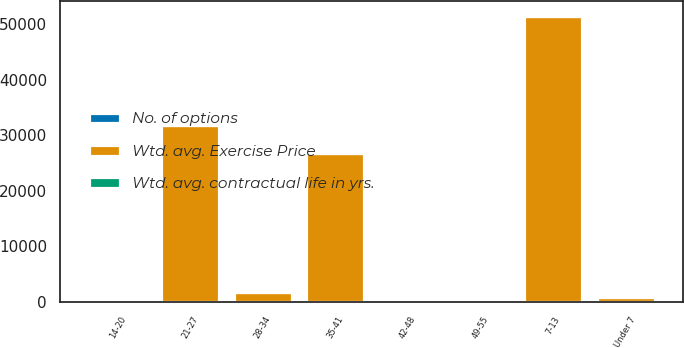Convert chart to OTSL. <chart><loc_0><loc_0><loc_500><loc_500><stacked_bar_chart><ecel><fcel>Under 7<fcel>7-13<fcel>14-20<fcel>21-27<fcel>28-34<fcel>35-41<fcel>42-48<fcel>49-55<nl><fcel>Wtd. avg. Exercise Price<fcel>907<fcel>51569<fcel>22<fcel>31923<fcel>1716<fcel>26865<fcel>332<fcel>36<nl><fcel>Wtd. avg. contractual life in yrs.<fcel>4<fcel>10<fcel>17<fcel>22<fcel>32<fcel>39<fcel>44<fcel>51<nl><fcel>No. of options<fcel>7<fcel>4<fcel>7<fcel>8<fcel>2<fcel>7<fcel>3<fcel>2<nl></chart> 